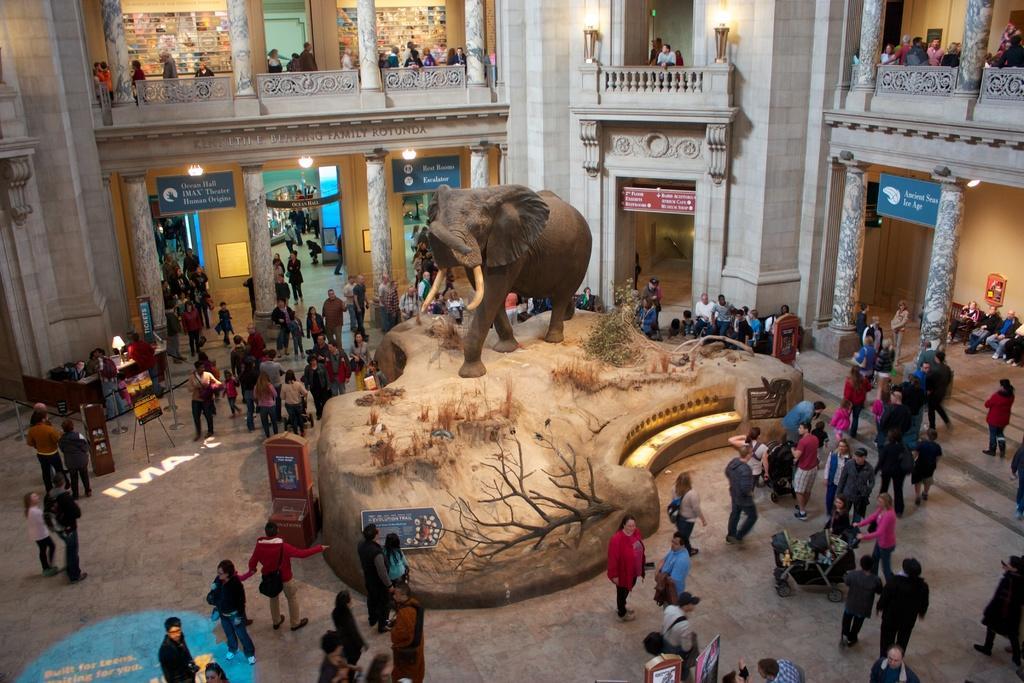How would you summarize this image in a sentence or two? In this image I can see there is an inside of the building. And there are groups of people standing and there are some objects. And there is a stone. On the stone there is a sculpture. And there is a board with text. 